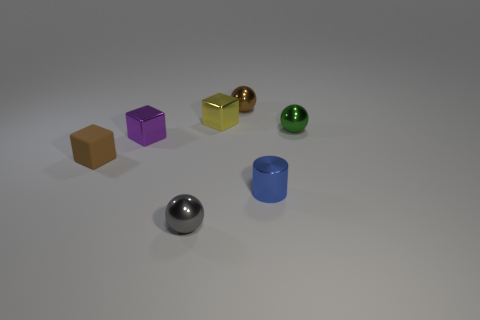There is a gray metallic thing that is the same size as the rubber object; what is its shape? sphere 